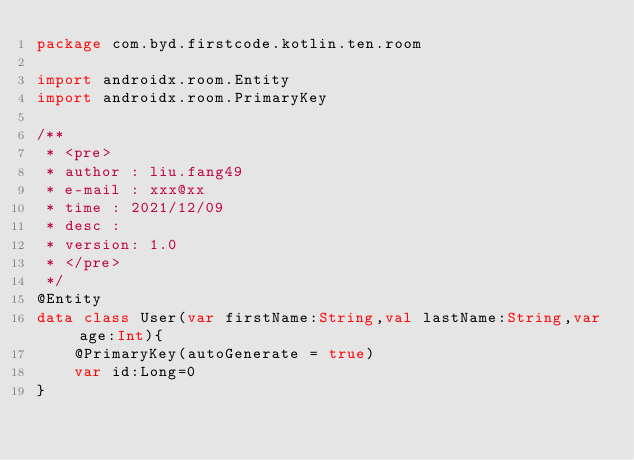<code> <loc_0><loc_0><loc_500><loc_500><_Kotlin_>package com.byd.firstcode.kotlin.ten.room

import androidx.room.Entity
import androidx.room.PrimaryKey

/**
 * <pre>
 * author : liu.fang49
 * e-mail : xxx@xx
 * time : 2021/12/09
 * desc :
 * version: 1.0
 * </pre>
 */
@Entity
data class User(var firstName:String,val lastName:String,var age:Int){
    @PrimaryKey(autoGenerate = true)
    var id:Long=0
}
</code> 